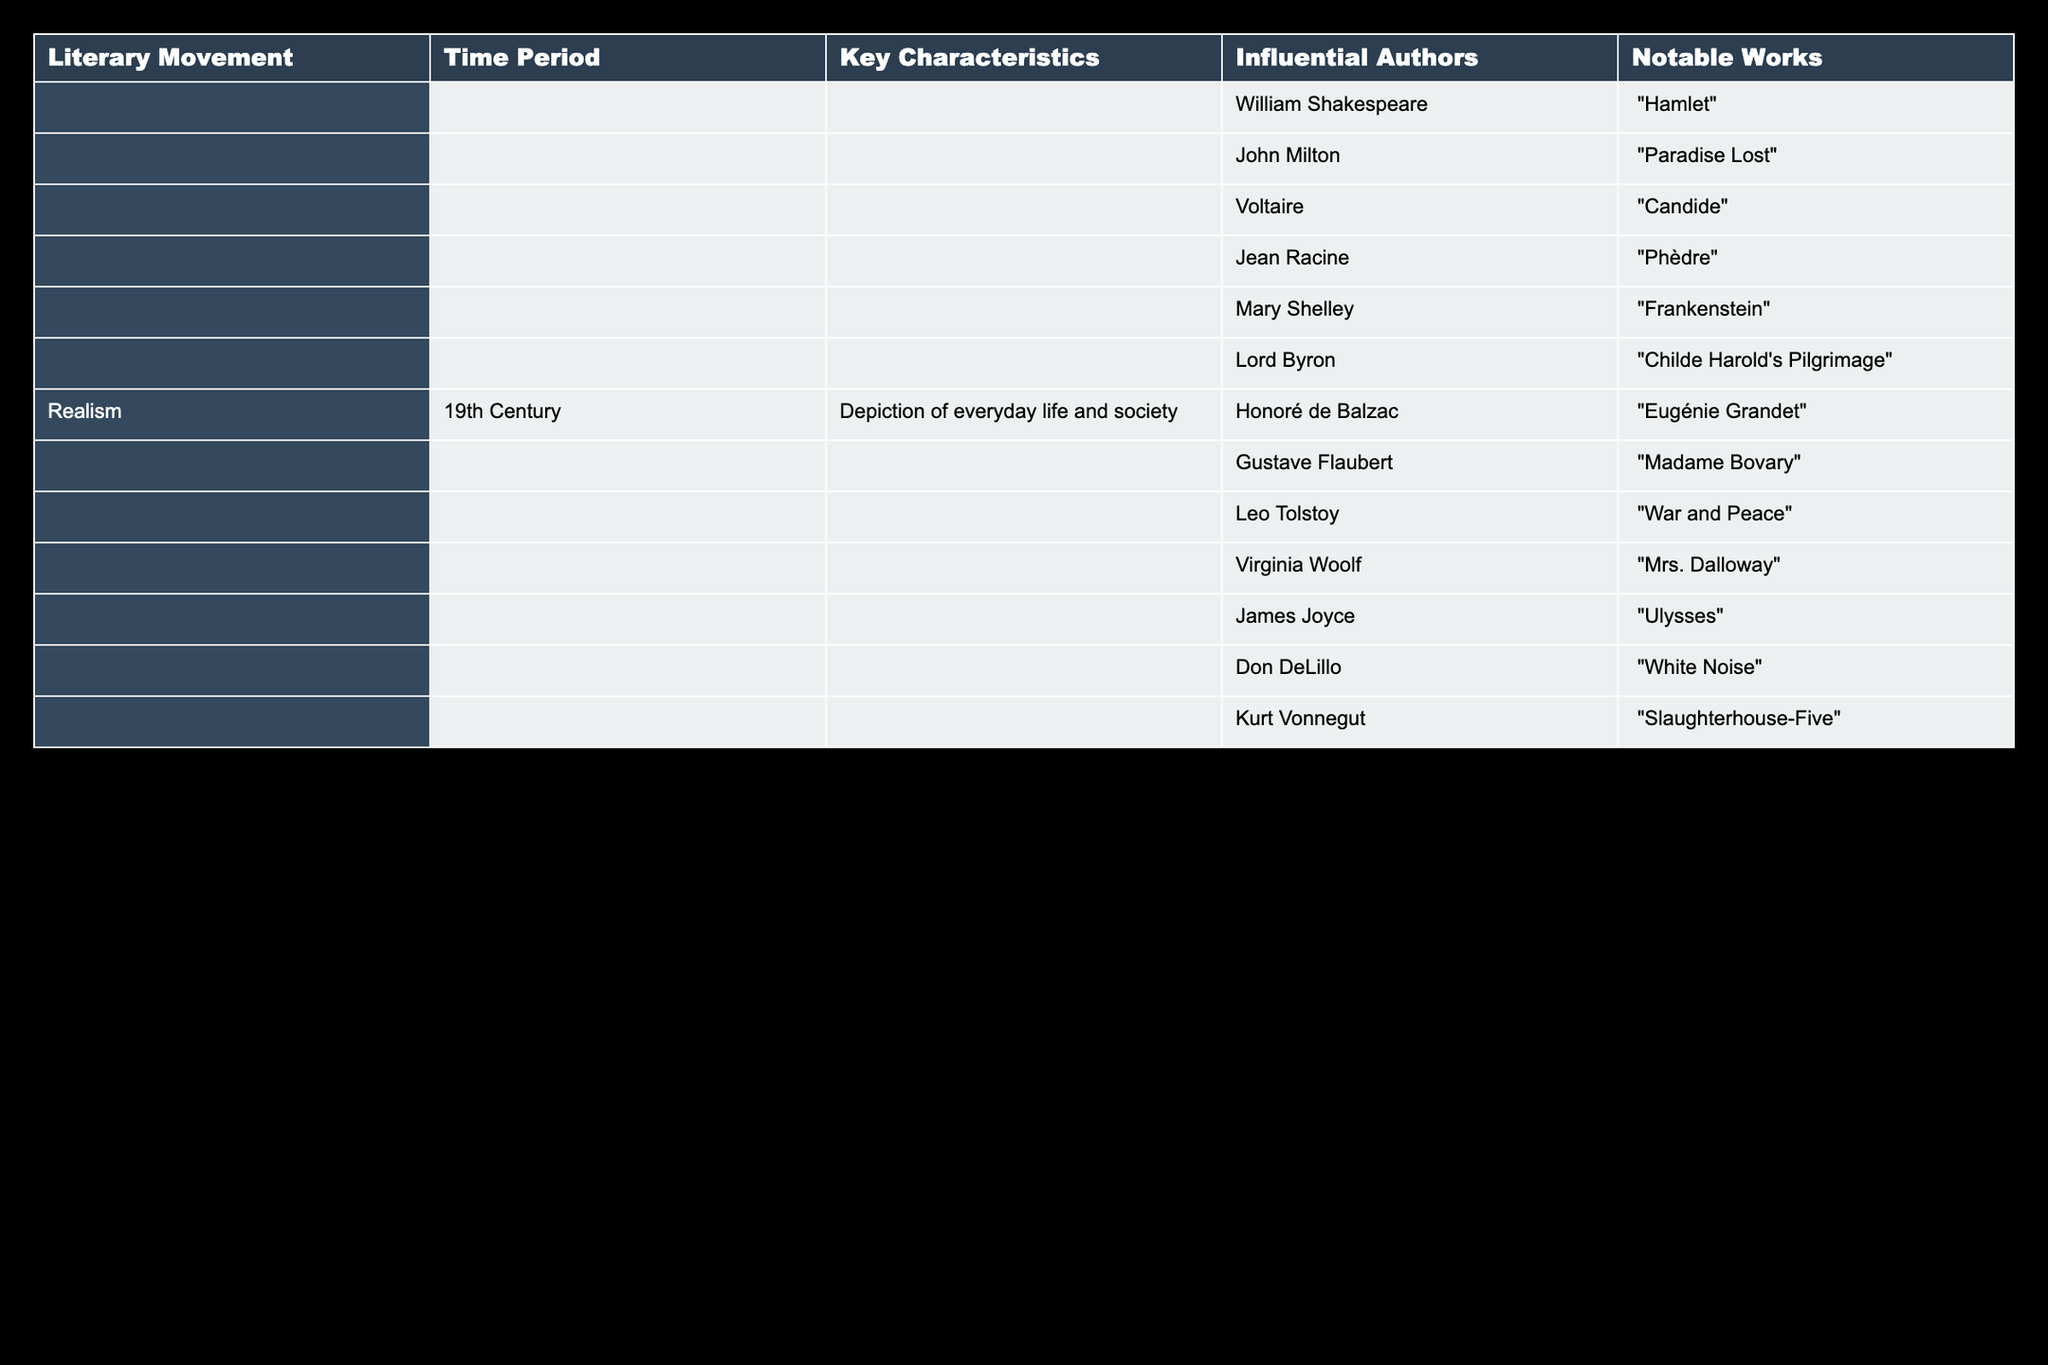What time period does the literary movement Realism belong to? The table clearly shows that the Realism literary movement is associated with the 19th Century time period.
Answer: 19th Century Which author wrote "War and Peace"? By looking under the Realism literary movement, we find that the author associated with the notable work "War and Peace" is Leo Tolstoy.
Answer: Leo Tolstoy True or False: Voltaire is an influential author of the Romantic movement. The table does not list Voltaire under the Romantic movement; he is included in the earlier movements, specifically Enlightenment. Hence, the statement is false.
Answer: False Which two authors have notable works that include "Mrs. Dalloway" and "Ulysses"? We can find their names under the Realism literary movement; Virginia Woolf wrote "Mrs. Dalloway" and James Joyce wrote "Ulysses."
Answer: Virginia Woolf and James Joyce What are the notable works of authors from the Enlightenment period listed in the table? The table does not explicitly state the Enlightenment period, but we can check by looking for authors who contributed to early literature. The works mentioned are "Candide" by Voltaire and "Phèdre" by Jean Racine. Therefore, the notable works are "Candide" and "Phèdre".
Answer: "Candide", "Phèdre" How many authors in total are listed under the Realism movement? The table lists a total of 7 authors under the Realism movement: Honoré de Balzac, Gustave Flaubert, Leo Tolstoy, Virginia Woolf, James Joyce, Don DeLillo, and Kurt Vonnegut. This gives us a total of 7 authors.
Answer: 7 Which literary movement is characterized by the depiction of everyday life and society? From the table, it's evident that Realism is the literary movement defined by the depiction of everyday life and society.
Answer: Realism What is the difference in the number of works noted between the Romantic and Realism movements? The Romantic movement highlighted a few works, with authors like Mary Shelley and Lord Byron listed; however, Realism has 7 notable works. Thus, we can summarize: Romantic has 2 noted works, and Realism has 7 noted works, leading to a difference of 5 notable works.
Answer: 5 